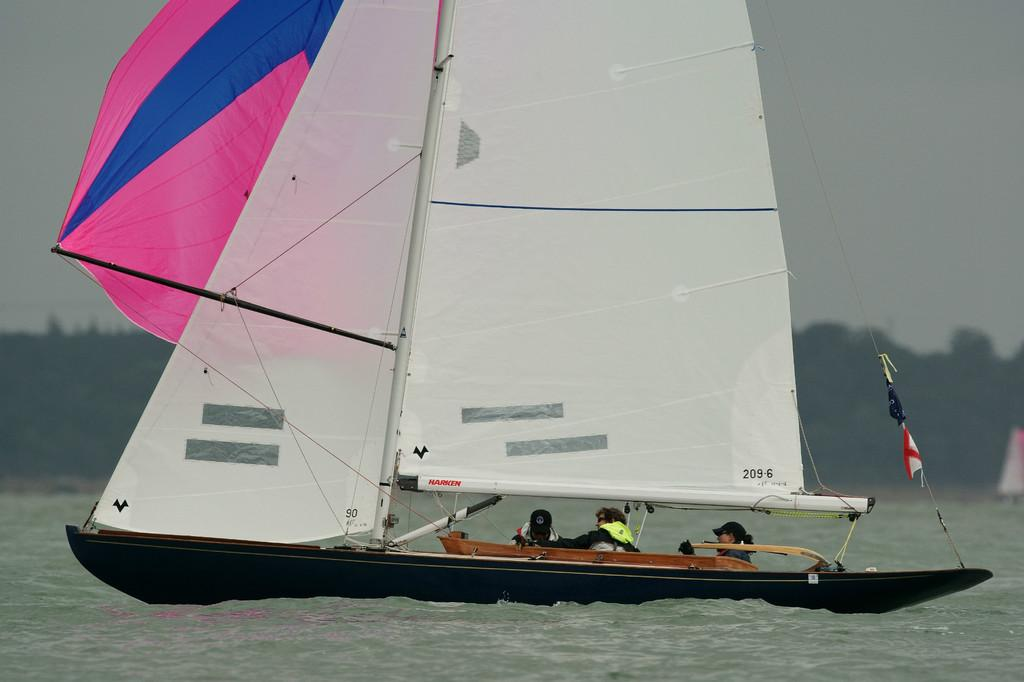What is happening in the image involving a group of people? The people are sailing in a boat. Where is the boat located in the image? The boat is in the water. What safety precaution are the people taking while sailing? The people are wearing life jackets. What type of sweater is the person wearing while sailing in the image? There is no sweater mentioned or visible in the image; the people are wearing life jackets. 